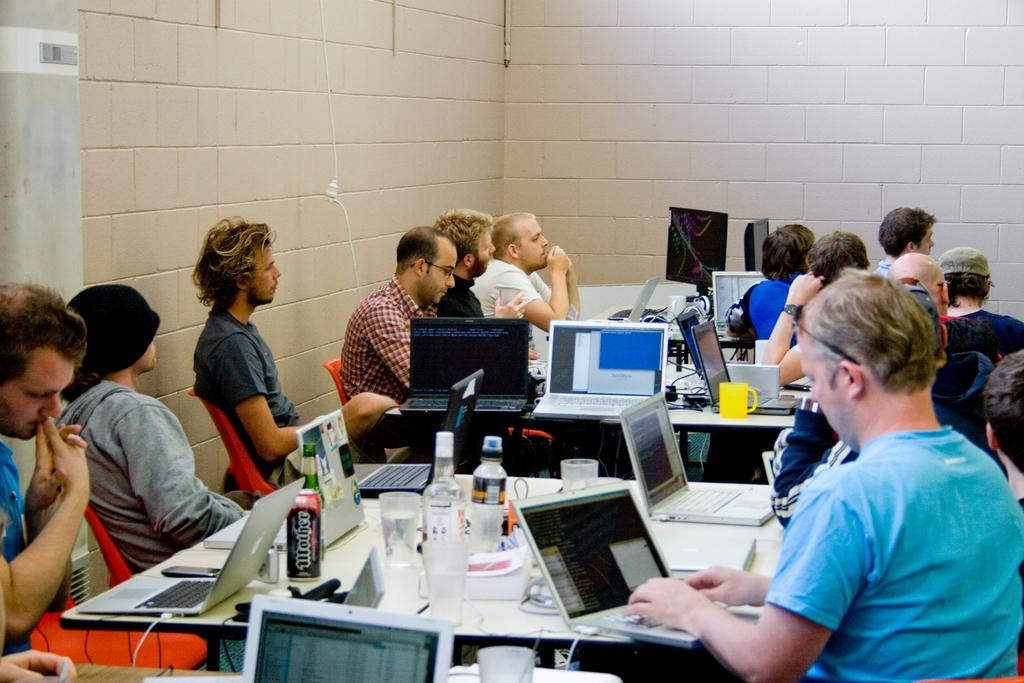What are the persons in the image doing? The persons in the image are sitting in chairs. What is in front of the persons? There is a table in front of the persons. What electronic devices are on the table? There are laptops on the table. What beverages are on the table? There are water bottles on the table. What is used for drinking on the table? There are glasses on the table. What other items are on the table that are not specified? There are other unspecified objects placed on the table. What type of flowers are on the persons' wrists in the image? There are no flowers or any reference to wrists in the image; the persons are simply sitting in chairs with a table in front of them. 